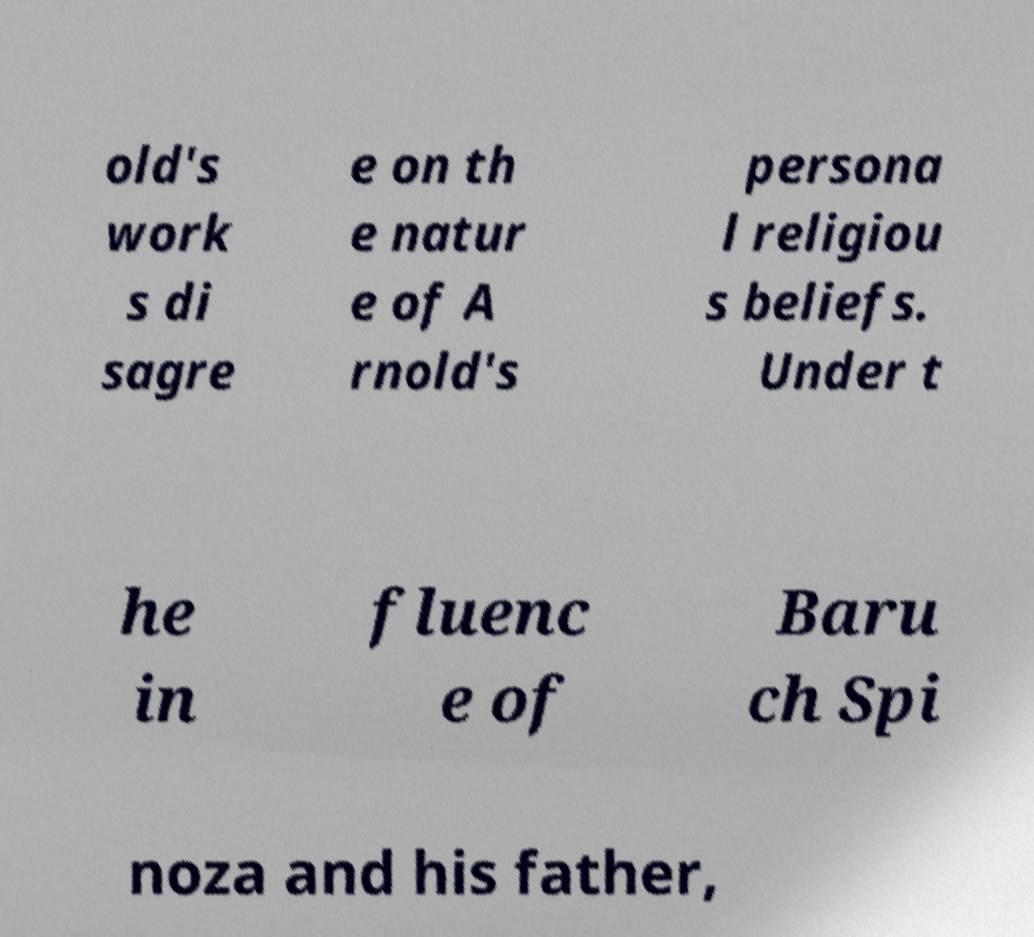Can you accurately transcribe the text from the provided image for me? old's work s di sagre e on th e natur e of A rnold's persona l religiou s beliefs. Under t he in fluenc e of Baru ch Spi noza and his father, 